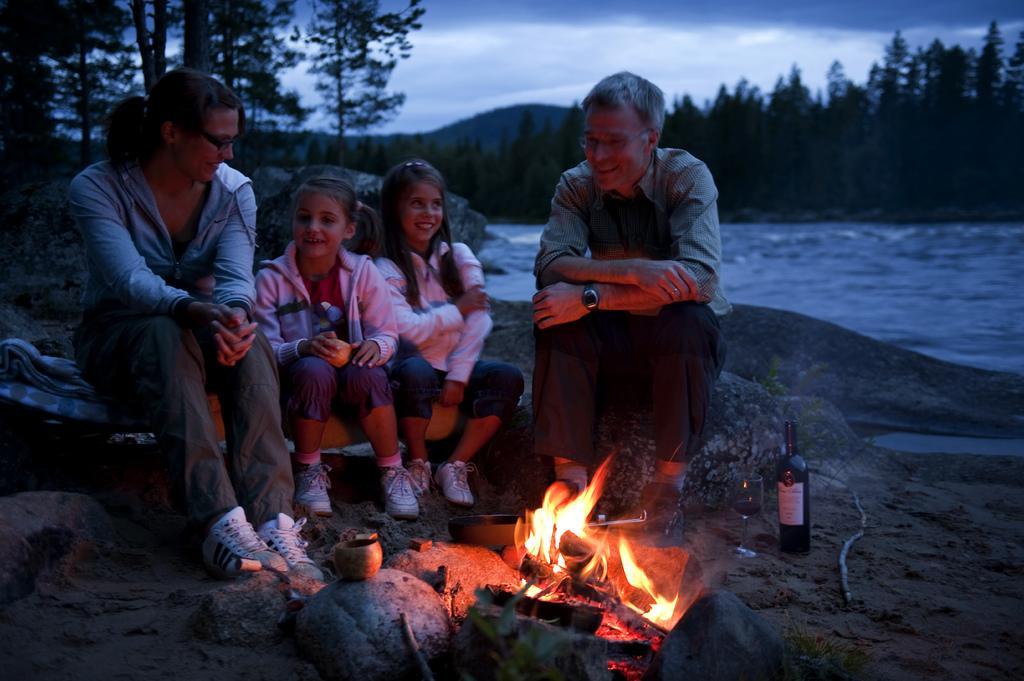Could you give a brief overview of what you see in this image? In the image we can see a man, a woman and two children sitting, they are wearing clothes, shoes and two of them are wearing spectacles. Here we can see the flame, stones, the bottle and the wine glass. Here we can see water, trees and the sky. 